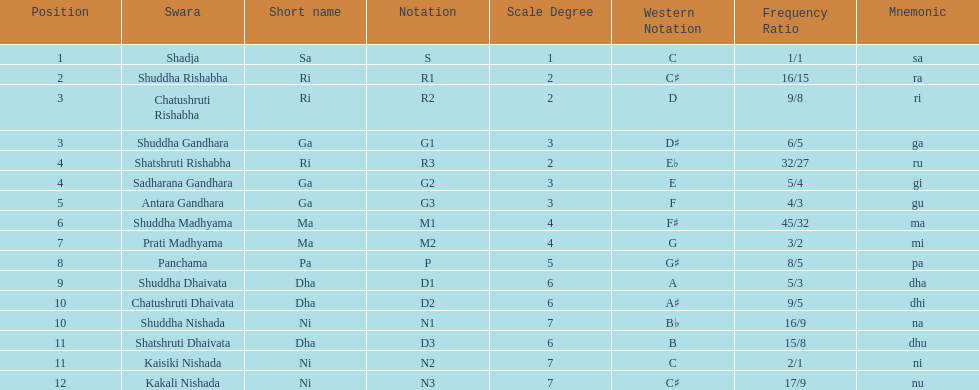On average how many of the swara have a short name that begin with d or g? 6. 